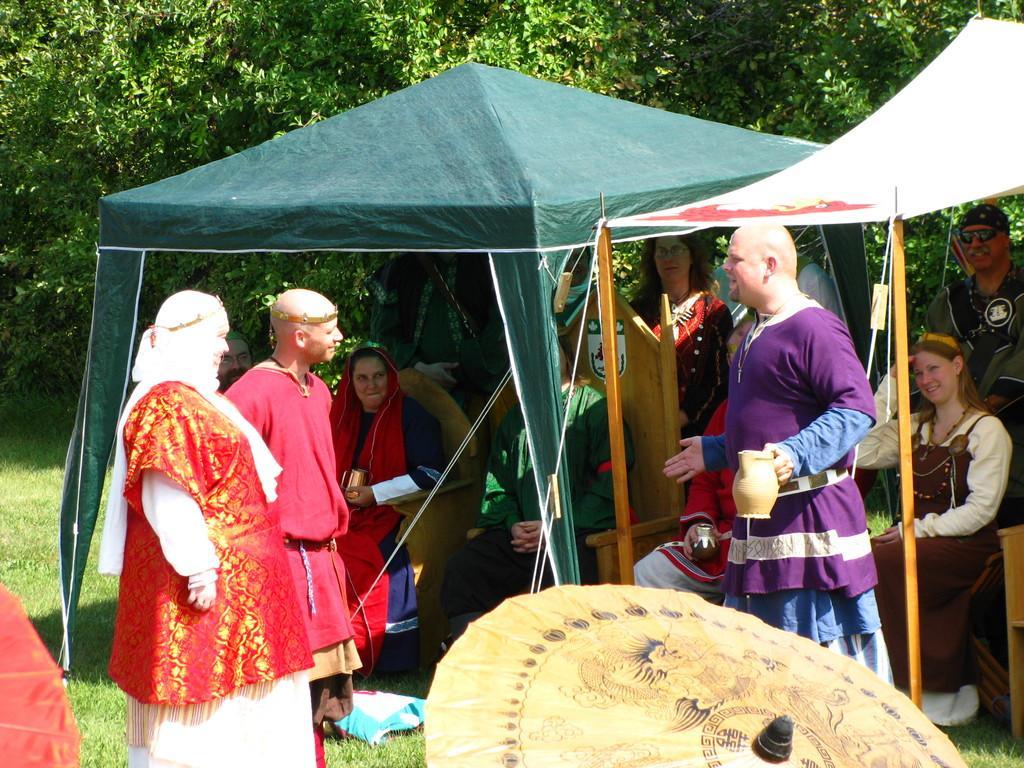In one or two sentences, can you explain what this image depicts? In this image we can see many people standing. Few are sitting on chairs. They are wearing costumes. One person is holding a jug. There are tents. On the ground there is grass. At the bottom there is an umbrella. In the background there are trees. 